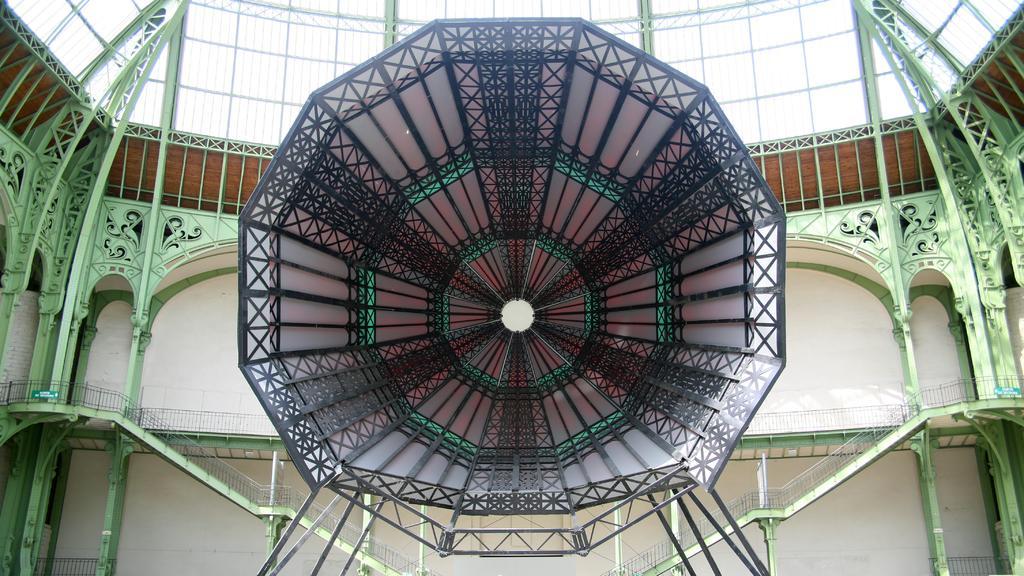Please provide a concise description of this image. In this image I can see inside view of a building. I can also see stairs, railings and here I can see something. 